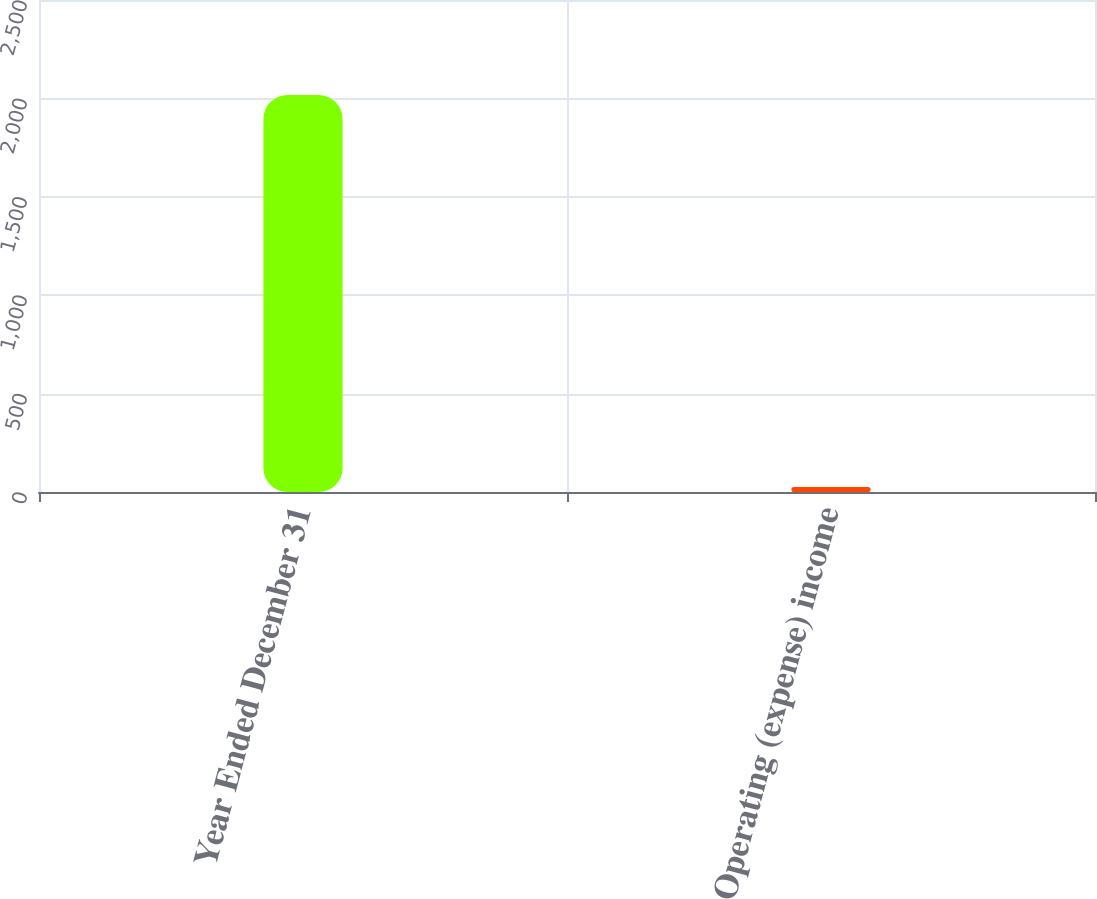Convert chart to OTSL. <chart><loc_0><loc_0><loc_500><loc_500><bar_chart><fcel>Year Ended December 31<fcel>Operating (expense) income<nl><fcel>2017<fcel>26<nl></chart> 